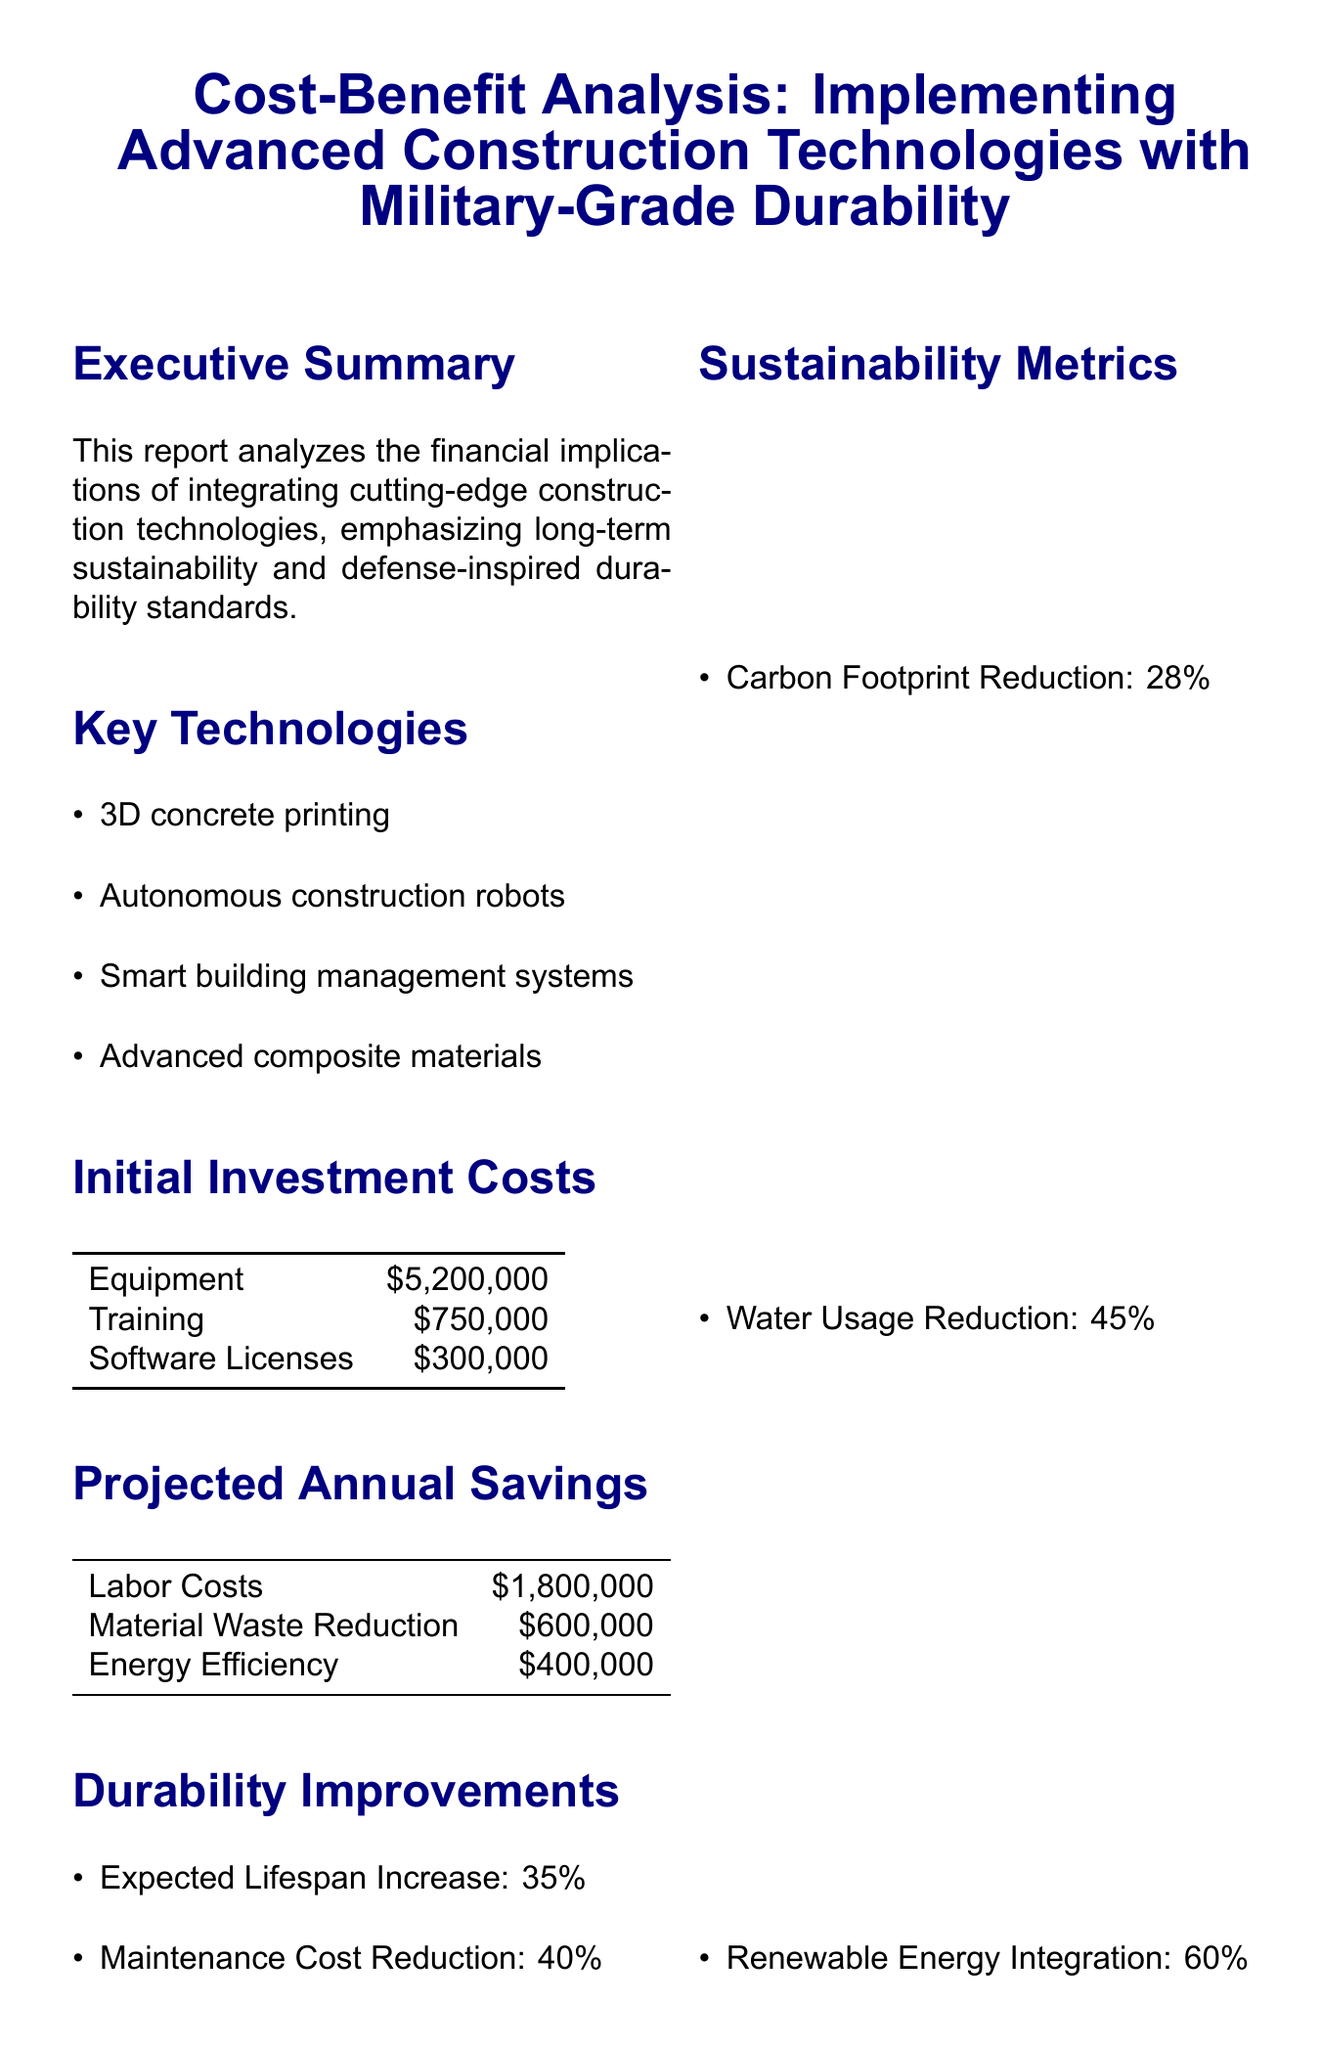What is the report title? The report title is specified at the beginning of the document, which provides an overview of the content.
Answer: Cost-Benefit Analysis: Implementing Advanced Construction Technologies with Military-Grade Durability What is the initial investment cost for equipment? The initial investment costs for equipment are detailed in the financial section of the report.
Answer: $5,200,000 What is the projected annual savings from labor costs? The projected annual savings from labor costs is explicitly stated in the projections for savings within the document.
Answer: $1,800,000 What percentage is the expected lifespan increase? The expected lifespan increase is mentioned under durability improvements, giving a clear percentage.
Answer: 35% What is the payback period for the investment? The payback period is calculated in the ROI analysis section and provides a specific timeframe for recovery of initial costs.
Answer: 4.2 years What is the internal rate of return? The internal rate of return is an important financial metric that is highlighted in the return on investment analysis.
Answer: 22% What sustainability metric shows the carbon footprint reduction? The sustainability metrics include various reductions, highlighting environmental benefits as specified in the report.
Answer: 28% What is the risk level for technology obsolescence? The risk assessment outlines various factors including their respective risk levels, providing insight into potential challenges.
Answer: Medium Which standard is related to chemical resistance? This standard is listed under defense-inspired standards, indicating specific compliance measures.
Answer: NFPA 1994 